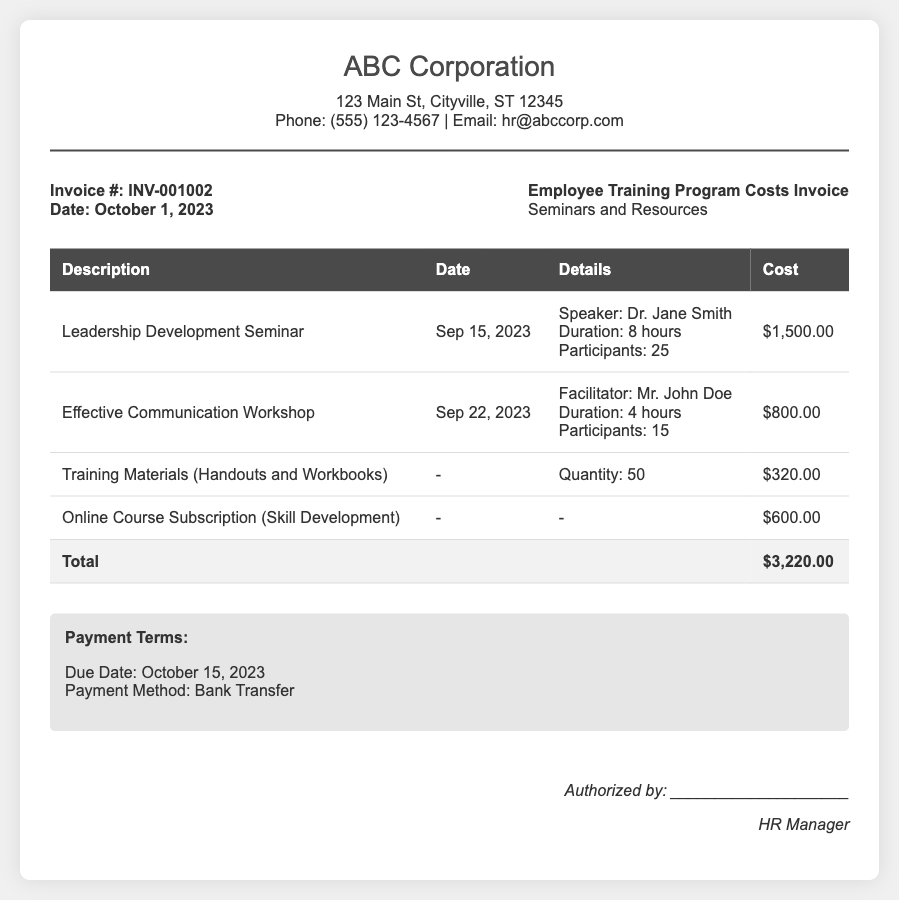What is the invoice number? The invoice number is stated in the document as INV-001002.
Answer: INV-001002 When was the Leadership Development Seminar held? The date of the Leadership Development Seminar is provided as September 15, 2023.
Answer: September 15, 2023 Who was the speaker for the Leadership Development Seminar? The speaker's name for the seminar is mentioned as Dr. Jane Smith.
Answer: Dr. Jane Smith What is the total cost for seminars and resources? The total cost combines all line items and is stated as $3,220.00.
Answer: $3,220.00 How many participants attended the Effective Communication Workshop? The document states that there were 15 participants for this workshop.
Answer: 15 What is the due date for payment? The due date for payment is specified in the document as October 15, 2023.
Answer: October 15, 2023 What is the payment method indicated in the invoice? The payment method mentioned in the document is Bank Transfer.
Answer: Bank Transfer What was the cost of the Training Materials? The cost for Training Materials (Handouts and Workbooks) is listed at $320.00.
Answer: $320.00 Who is the authorized signatory? The document mentions the signatory position as HR Manager.
Answer: HR Manager 